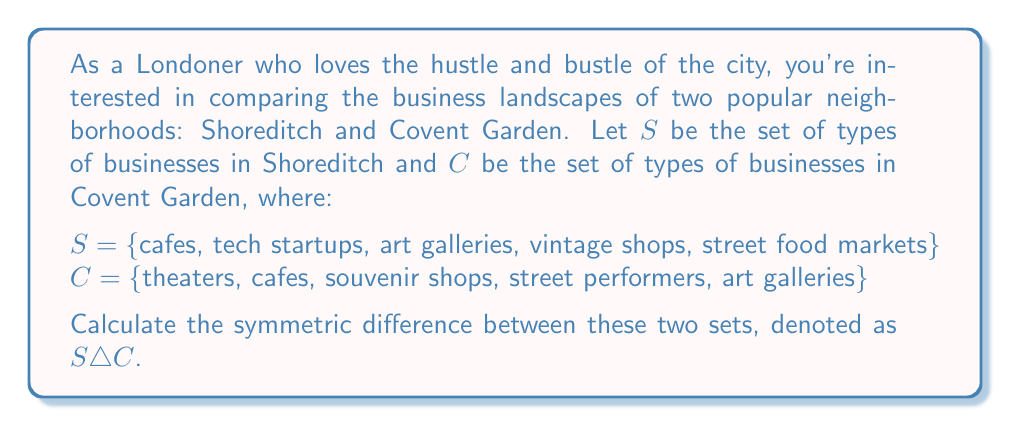Help me with this question. To solve this problem, we need to understand the concept of symmetric difference and then apply it to the given sets.

1) The symmetric difference of two sets $A$ and $B$, denoted as $A \triangle B$, is the set of elements that are in either $A$ or $B$, but not in both. It can be expressed as:

   $A \triangle B = (A \setminus B) \cup (B \setminus A)$

   where $\setminus$ represents set difference.

2) Let's first identify the elements that are in $S$ but not in $C$:
   $S \setminus C = \{$tech startups, vintage shops, street food markets$\}$

3) Now, let's identify the elements that are in $C$ but not in $S$:
   $C \setminus S = \{$theaters, souvenir shops, street performers$\}$

4) The symmetric difference is the union of these two sets:
   $S \triangle C = (S \setminus C) \cup (C \setminus S)$
                 $= \{$tech startups, vintage shops, street food markets, theaters, souvenir shops, street performers$\}$

5) Note that cafes and art galleries are present in both sets, so they are not included in the symmetric difference.

This result shows the unique business types that differentiate Shoreditch and Covent Garden, highlighting the distinct character of each neighborhood.
Answer: $S \triangle C = \{$tech startups, vintage shops, street food markets, theaters, souvenir shops, street performers$\}$ 